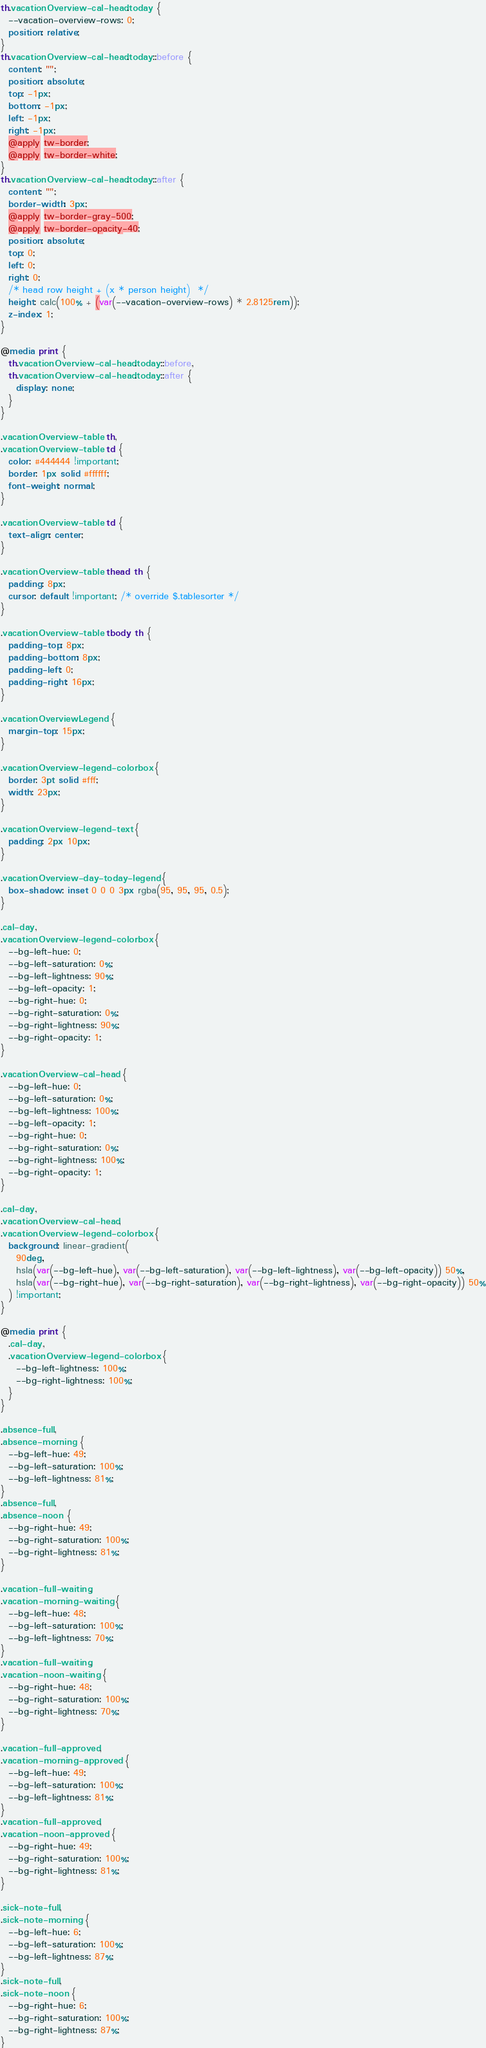Convert code to text. <code><loc_0><loc_0><loc_500><loc_500><_CSS_>th.vacationOverview-cal-head.today {
  --vacation-overview-rows: 0;
  position: relative;
}
th.vacationOverview-cal-head.today::before {
  content: "";
  position: absolute;
  top: -1px;
  bottom: -1px;
  left: -1px;
  right: -1px;
  @apply tw-border;
  @apply tw-border-white;
}
th.vacationOverview-cal-head.today::after {
  content: "";
  border-width: 3px;
  @apply tw-border-gray-500;
  @apply tw-border-opacity-40;
  position: absolute;
  top: 0;
  left: 0;
  right: 0;
  /* head row height + (x * person height)  */
  height: calc(100% + (var(--vacation-overview-rows) * 2.8125rem));
  z-index: 1;
}

@media print {
  th.vacationOverview-cal-head.today::before,
  th.vacationOverview-cal-head.today::after {
    display: none;
  }
}

.vacationOverview-table th,
.vacationOverview-table td {
  color: #444444 !important;
  border: 1px solid #ffffff;
  font-weight: normal;
}

.vacationOverview-table td {
  text-align: center;
}

.vacationOverview-table thead th {
  padding: 8px;
  cursor: default !important; /* override $.tablesorter */
}

.vacationOverview-table tbody th {
  padding-top: 8px;
  padding-bottom: 8px;
  padding-left: 0;
  padding-right: 16px;
}

.vacationOverviewLegend {
  margin-top: 15px;
}

.vacationOverview-legend-colorbox {
  border: 3pt solid #fff;
  width: 23px;
}

.vacationOverview-legend-text {
  padding: 2px 10px;
}

.vacationOverview-day-today-legend {
  box-shadow: inset 0 0 0 3px rgba(95, 95, 95, 0.5);
}

.cal-day,
.vacationOverview-legend-colorbox {
  --bg-left-hue: 0;
  --bg-left-saturation: 0%;
  --bg-left-lightness: 90%;
  --bg-left-opacity: 1;
  --bg-right-hue: 0;
  --bg-right-saturation: 0%;
  --bg-right-lightness: 90%;
  --bg-right-opacity: 1;
}

.vacationOverview-cal-head {
  --bg-left-hue: 0;
  --bg-left-saturation: 0%;
  --bg-left-lightness: 100%;
  --bg-left-opacity: 1;
  --bg-right-hue: 0;
  --bg-right-saturation: 0%;
  --bg-right-lightness: 100%;
  --bg-right-opacity: 1;
}

.cal-day,
.vacationOverview-cal-head,
.vacationOverview-legend-colorbox {
  background: linear-gradient(
    90deg,
    hsla(var(--bg-left-hue), var(--bg-left-saturation), var(--bg-left-lightness), var(--bg-left-opacity)) 50%,
    hsla(var(--bg-right-hue), var(--bg-right-saturation), var(--bg-right-lightness), var(--bg-right-opacity)) 50%
  ) !important;
}

@media print {
  .cal-day,
  .vacationOverview-legend-colorbox {
    --bg-left-lightness: 100%;
    --bg-right-lightness: 100%;
  }
}

.absence-full,
.absence-morning {
  --bg-left-hue: 49;
  --bg-left-saturation: 100%;
  --bg-left-lightness: 81%;
}
.absence-full,
.absence-noon {
  --bg-right-hue: 49;
  --bg-right-saturation: 100%;
  --bg-right-lightness: 81%;
}

.vacation-full-waiting,
.vacation-morning-waiting {
  --bg-left-hue: 48;
  --bg-left-saturation: 100%;
  --bg-left-lightness: 70%;
}
.vacation-full-waiting,
.vacation-noon-waiting {
  --bg-right-hue: 48;
  --bg-right-saturation: 100%;
  --bg-right-lightness: 70%;
}

.vacation-full-approved,
.vacation-morning-approved {
  --bg-left-hue: 49;
  --bg-left-saturation: 100%;
  --bg-left-lightness: 81%;
}
.vacation-full-approved,
.vacation-noon-approved {
  --bg-right-hue: 49;
  --bg-right-saturation: 100%;
  --bg-right-lightness: 81%;
}

.sick-note-full,
.sick-note-morning {
  --bg-left-hue: 6;
  --bg-left-saturation: 100%;
  --bg-left-lightness: 87%;
}
.sick-note-full,
.sick-note-noon {
  --bg-right-hue: 6;
  --bg-right-saturation: 100%;
  --bg-right-lightness: 87%;
}
</code> 